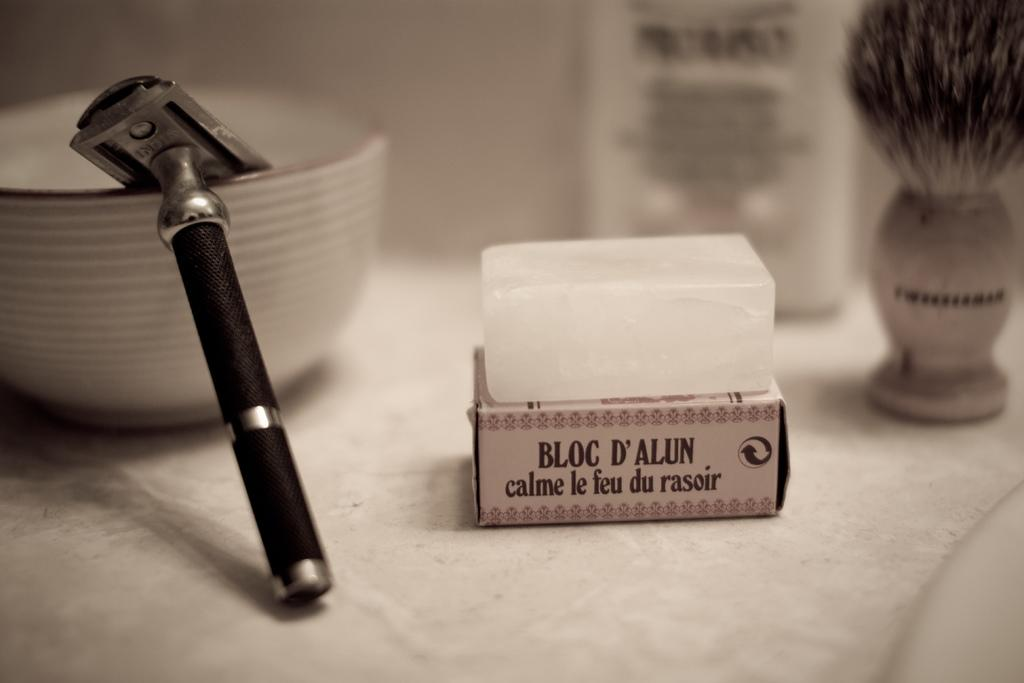<image>
Provide a brief description of the given image. A bloc d'alun sits on a marble counter next to a razor. 